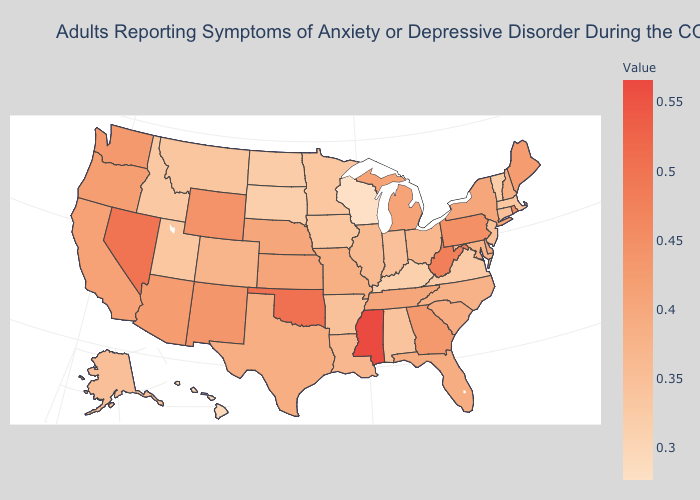Among the states that border Wisconsin , which have the highest value?
Answer briefly. Michigan. Does New Jersey have a higher value than Rhode Island?
Concise answer only. No. Among the states that border West Virginia , does Kentucky have the lowest value?
Be succinct. Yes. Does Arizona have a higher value than West Virginia?
Answer briefly. No. Among the states that border Delaware , does Pennsylvania have the lowest value?
Short answer required. No. Does Mississippi have the highest value in the USA?
Be succinct. Yes. 